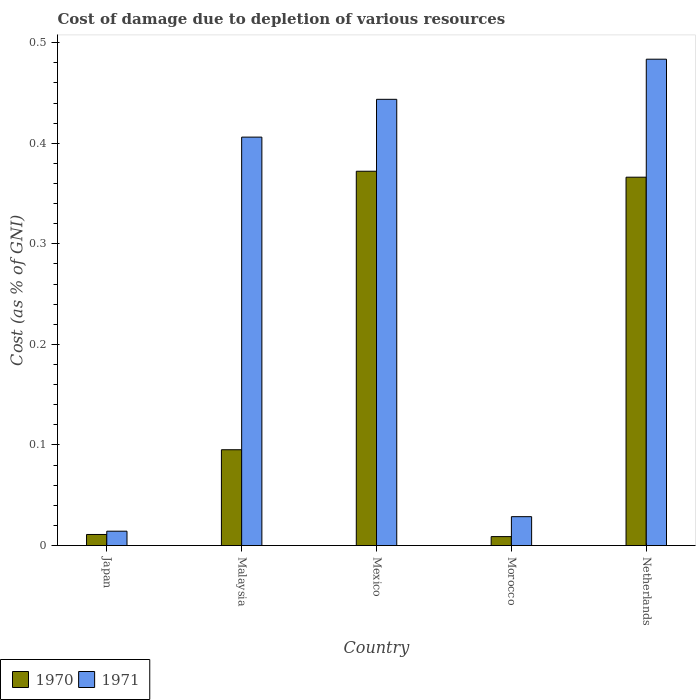How many different coloured bars are there?
Ensure brevity in your answer.  2. How many bars are there on the 5th tick from the left?
Offer a very short reply. 2. What is the cost of damage caused due to the depletion of various resources in 1971 in Japan?
Offer a very short reply. 0.01. Across all countries, what is the maximum cost of damage caused due to the depletion of various resources in 1971?
Offer a terse response. 0.48. Across all countries, what is the minimum cost of damage caused due to the depletion of various resources in 1970?
Provide a succinct answer. 0.01. In which country was the cost of damage caused due to the depletion of various resources in 1970 maximum?
Give a very brief answer. Mexico. What is the total cost of damage caused due to the depletion of various resources in 1970 in the graph?
Make the answer very short. 0.85. What is the difference between the cost of damage caused due to the depletion of various resources in 1970 in Japan and that in Netherlands?
Provide a short and direct response. -0.36. What is the difference between the cost of damage caused due to the depletion of various resources in 1971 in Mexico and the cost of damage caused due to the depletion of various resources in 1970 in Malaysia?
Offer a terse response. 0.35. What is the average cost of damage caused due to the depletion of various resources in 1971 per country?
Offer a terse response. 0.28. What is the difference between the cost of damage caused due to the depletion of various resources of/in 1971 and cost of damage caused due to the depletion of various resources of/in 1970 in Malaysia?
Offer a very short reply. 0.31. In how many countries, is the cost of damage caused due to the depletion of various resources in 1971 greater than 0.14 %?
Keep it short and to the point. 3. What is the ratio of the cost of damage caused due to the depletion of various resources in 1970 in Malaysia to that in Morocco?
Make the answer very short. 10.69. What is the difference between the highest and the second highest cost of damage caused due to the depletion of various resources in 1971?
Your response must be concise. 0.08. What is the difference between the highest and the lowest cost of damage caused due to the depletion of various resources in 1971?
Give a very brief answer. 0.47. In how many countries, is the cost of damage caused due to the depletion of various resources in 1970 greater than the average cost of damage caused due to the depletion of various resources in 1970 taken over all countries?
Ensure brevity in your answer.  2. Is the sum of the cost of damage caused due to the depletion of various resources in 1970 in Mexico and Morocco greater than the maximum cost of damage caused due to the depletion of various resources in 1971 across all countries?
Give a very brief answer. No. What does the 1st bar from the right in Netherlands represents?
Provide a succinct answer. 1971. How many bars are there?
Make the answer very short. 10. Are all the bars in the graph horizontal?
Offer a very short reply. No. How many countries are there in the graph?
Provide a succinct answer. 5. What is the difference between two consecutive major ticks on the Y-axis?
Offer a terse response. 0.1. Are the values on the major ticks of Y-axis written in scientific E-notation?
Offer a terse response. No. Does the graph contain any zero values?
Provide a short and direct response. No. How are the legend labels stacked?
Give a very brief answer. Horizontal. What is the title of the graph?
Provide a succinct answer. Cost of damage due to depletion of various resources. Does "2004" appear as one of the legend labels in the graph?
Your answer should be compact. No. What is the label or title of the Y-axis?
Your answer should be very brief. Cost (as % of GNI). What is the Cost (as % of GNI) in 1970 in Japan?
Give a very brief answer. 0.01. What is the Cost (as % of GNI) of 1971 in Japan?
Give a very brief answer. 0.01. What is the Cost (as % of GNI) of 1970 in Malaysia?
Offer a very short reply. 0.1. What is the Cost (as % of GNI) in 1971 in Malaysia?
Give a very brief answer. 0.41. What is the Cost (as % of GNI) in 1970 in Mexico?
Offer a terse response. 0.37. What is the Cost (as % of GNI) of 1971 in Mexico?
Your response must be concise. 0.44. What is the Cost (as % of GNI) in 1970 in Morocco?
Keep it short and to the point. 0.01. What is the Cost (as % of GNI) in 1971 in Morocco?
Make the answer very short. 0.03. What is the Cost (as % of GNI) of 1970 in Netherlands?
Ensure brevity in your answer.  0.37. What is the Cost (as % of GNI) in 1971 in Netherlands?
Provide a succinct answer. 0.48. Across all countries, what is the maximum Cost (as % of GNI) of 1970?
Your response must be concise. 0.37. Across all countries, what is the maximum Cost (as % of GNI) in 1971?
Give a very brief answer. 0.48. Across all countries, what is the minimum Cost (as % of GNI) in 1970?
Ensure brevity in your answer.  0.01. Across all countries, what is the minimum Cost (as % of GNI) of 1971?
Offer a very short reply. 0.01. What is the total Cost (as % of GNI) of 1970 in the graph?
Your response must be concise. 0.85. What is the total Cost (as % of GNI) in 1971 in the graph?
Ensure brevity in your answer.  1.38. What is the difference between the Cost (as % of GNI) in 1970 in Japan and that in Malaysia?
Offer a very short reply. -0.08. What is the difference between the Cost (as % of GNI) of 1971 in Japan and that in Malaysia?
Offer a very short reply. -0.39. What is the difference between the Cost (as % of GNI) of 1970 in Japan and that in Mexico?
Offer a very short reply. -0.36. What is the difference between the Cost (as % of GNI) of 1971 in Japan and that in Mexico?
Your answer should be very brief. -0.43. What is the difference between the Cost (as % of GNI) in 1970 in Japan and that in Morocco?
Provide a short and direct response. 0. What is the difference between the Cost (as % of GNI) in 1971 in Japan and that in Morocco?
Your answer should be very brief. -0.01. What is the difference between the Cost (as % of GNI) in 1970 in Japan and that in Netherlands?
Provide a short and direct response. -0.36. What is the difference between the Cost (as % of GNI) of 1971 in Japan and that in Netherlands?
Give a very brief answer. -0.47. What is the difference between the Cost (as % of GNI) of 1970 in Malaysia and that in Mexico?
Provide a short and direct response. -0.28. What is the difference between the Cost (as % of GNI) of 1971 in Malaysia and that in Mexico?
Ensure brevity in your answer.  -0.04. What is the difference between the Cost (as % of GNI) of 1970 in Malaysia and that in Morocco?
Offer a terse response. 0.09. What is the difference between the Cost (as % of GNI) of 1971 in Malaysia and that in Morocco?
Provide a short and direct response. 0.38. What is the difference between the Cost (as % of GNI) of 1970 in Malaysia and that in Netherlands?
Offer a very short reply. -0.27. What is the difference between the Cost (as % of GNI) of 1971 in Malaysia and that in Netherlands?
Provide a succinct answer. -0.08. What is the difference between the Cost (as % of GNI) of 1970 in Mexico and that in Morocco?
Give a very brief answer. 0.36. What is the difference between the Cost (as % of GNI) in 1971 in Mexico and that in Morocco?
Offer a terse response. 0.41. What is the difference between the Cost (as % of GNI) of 1970 in Mexico and that in Netherlands?
Your answer should be very brief. 0.01. What is the difference between the Cost (as % of GNI) in 1971 in Mexico and that in Netherlands?
Offer a terse response. -0.04. What is the difference between the Cost (as % of GNI) in 1970 in Morocco and that in Netherlands?
Offer a very short reply. -0.36. What is the difference between the Cost (as % of GNI) of 1971 in Morocco and that in Netherlands?
Keep it short and to the point. -0.45. What is the difference between the Cost (as % of GNI) of 1970 in Japan and the Cost (as % of GNI) of 1971 in Malaysia?
Your answer should be very brief. -0.4. What is the difference between the Cost (as % of GNI) in 1970 in Japan and the Cost (as % of GNI) in 1971 in Mexico?
Keep it short and to the point. -0.43. What is the difference between the Cost (as % of GNI) of 1970 in Japan and the Cost (as % of GNI) of 1971 in Morocco?
Your response must be concise. -0.02. What is the difference between the Cost (as % of GNI) of 1970 in Japan and the Cost (as % of GNI) of 1971 in Netherlands?
Keep it short and to the point. -0.47. What is the difference between the Cost (as % of GNI) in 1970 in Malaysia and the Cost (as % of GNI) in 1971 in Mexico?
Your response must be concise. -0.35. What is the difference between the Cost (as % of GNI) of 1970 in Malaysia and the Cost (as % of GNI) of 1971 in Morocco?
Ensure brevity in your answer.  0.07. What is the difference between the Cost (as % of GNI) in 1970 in Malaysia and the Cost (as % of GNI) in 1971 in Netherlands?
Offer a very short reply. -0.39. What is the difference between the Cost (as % of GNI) in 1970 in Mexico and the Cost (as % of GNI) in 1971 in Morocco?
Offer a very short reply. 0.34. What is the difference between the Cost (as % of GNI) of 1970 in Mexico and the Cost (as % of GNI) of 1971 in Netherlands?
Your answer should be very brief. -0.11. What is the difference between the Cost (as % of GNI) of 1970 in Morocco and the Cost (as % of GNI) of 1971 in Netherlands?
Offer a terse response. -0.47. What is the average Cost (as % of GNI) of 1970 per country?
Keep it short and to the point. 0.17. What is the average Cost (as % of GNI) of 1971 per country?
Make the answer very short. 0.28. What is the difference between the Cost (as % of GNI) in 1970 and Cost (as % of GNI) in 1971 in Japan?
Offer a very short reply. -0. What is the difference between the Cost (as % of GNI) of 1970 and Cost (as % of GNI) of 1971 in Malaysia?
Give a very brief answer. -0.31. What is the difference between the Cost (as % of GNI) of 1970 and Cost (as % of GNI) of 1971 in Mexico?
Your response must be concise. -0.07. What is the difference between the Cost (as % of GNI) of 1970 and Cost (as % of GNI) of 1971 in Morocco?
Provide a succinct answer. -0.02. What is the difference between the Cost (as % of GNI) of 1970 and Cost (as % of GNI) of 1971 in Netherlands?
Your answer should be compact. -0.12. What is the ratio of the Cost (as % of GNI) of 1970 in Japan to that in Malaysia?
Your answer should be very brief. 0.12. What is the ratio of the Cost (as % of GNI) in 1971 in Japan to that in Malaysia?
Offer a terse response. 0.04. What is the ratio of the Cost (as % of GNI) in 1970 in Japan to that in Mexico?
Ensure brevity in your answer.  0.03. What is the ratio of the Cost (as % of GNI) in 1971 in Japan to that in Mexico?
Keep it short and to the point. 0.03. What is the ratio of the Cost (as % of GNI) of 1970 in Japan to that in Morocco?
Give a very brief answer. 1.24. What is the ratio of the Cost (as % of GNI) of 1971 in Japan to that in Morocco?
Provide a succinct answer. 0.5. What is the ratio of the Cost (as % of GNI) in 1970 in Japan to that in Netherlands?
Your answer should be very brief. 0.03. What is the ratio of the Cost (as % of GNI) of 1971 in Japan to that in Netherlands?
Ensure brevity in your answer.  0.03. What is the ratio of the Cost (as % of GNI) of 1970 in Malaysia to that in Mexico?
Your answer should be very brief. 0.26. What is the ratio of the Cost (as % of GNI) in 1971 in Malaysia to that in Mexico?
Offer a terse response. 0.92. What is the ratio of the Cost (as % of GNI) of 1970 in Malaysia to that in Morocco?
Your answer should be compact. 10.69. What is the ratio of the Cost (as % of GNI) in 1971 in Malaysia to that in Morocco?
Provide a succinct answer. 14.13. What is the ratio of the Cost (as % of GNI) in 1970 in Malaysia to that in Netherlands?
Give a very brief answer. 0.26. What is the ratio of the Cost (as % of GNI) of 1971 in Malaysia to that in Netherlands?
Ensure brevity in your answer.  0.84. What is the ratio of the Cost (as % of GNI) of 1970 in Mexico to that in Morocco?
Offer a very short reply. 41.78. What is the ratio of the Cost (as % of GNI) in 1971 in Mexico to that in Morocco?
Ensure brevity in your answer.  15.44. What is the ratio of the Cost (as % of GNI) in 1970 in Mexico to that in Netherlands?
Ensure brevity in your answer.  1.02. What is the ratio of the Cost (as % of GNI) in 1971 in Mexico to that in Netherlands?
Your response must be concise. 0.92. What is the ratio of the Cost (as % of GNI) of 1970 in Morocco to that in Netherlands?
Provide a short and direct response. 0.02. What is the ratio of the Cost (as % of GNI) in 1971 in Morocco to that in Netherlands?
Offer a very short reply. 0.06. What is the difference between the highest and the second highest Cost (as % of GNI) in 1970?
Give a very brief answer. 0.01. What is the difference between the highest and the second highest Cost (as % of GNI) of 1971?
Offer a terse response. 0.04. What is the difference between the highest and the lowest Cost (as % of GNI) of 1970?
Keep it short and to the point. 0.36. What is the difference between the highest and the lowest Cost (as % of GNI) of 1971?
Make the answer very short. 0.47. 